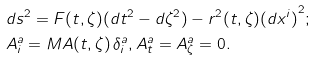Convert formula to latex. <formula><loc_0><loc_0><loc_500><loc_500>& d s ^ { 2 } = F ( t , \zeta ) ( d t ^ { 2 } - d \zeta ^ { 2 } ) - r ^ { 2 } ( t , \zeta ) { ( d x ^ { i } ) } ^ { 2 } ; \\ & A ^ { a } _ { i } = M A ( t , \zeta ) \, \delta ^ { a } _ { i } , A ^ { a } _ { t } = A ^ { a } _ { \zeta } = 0 .</formula> 